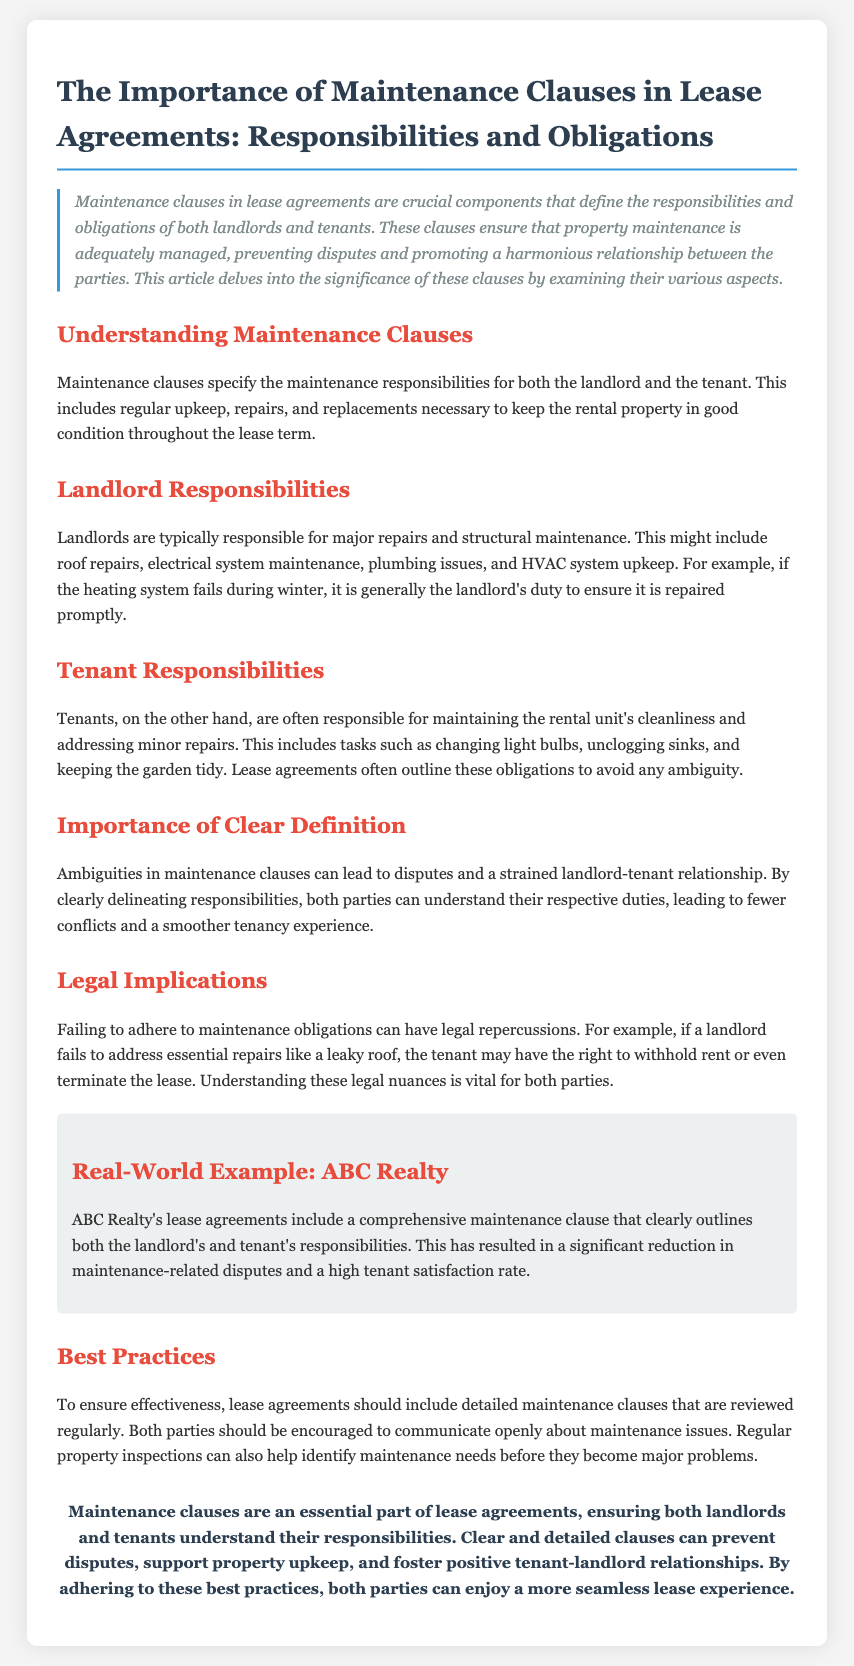What are maintenance clauses? Maintenance clauses specify the maintenance responsibilities for both the landlord and the tenant throughout the lease term.
Answer: Maintenance responsibilities Who is responsible for major repairs? Major repairs and structural maintenance are typically the responsibility of the landlord.
Answer: Landlord Give an example of a tenant responsibility. Tenant responsibilities include tasks such as changing light bulbs or unclogging sinks.
Answer: Changing light bulbs What can happen if a landlord fails to address essential repairs? Failing to address essential repairs can lead to legal repercussions such as the tenant withholding rent.
Answer: Withholding rent What is a best practice for lease agreements? A best practice is to include detailed maintenance clauses that are reviewed regularly.
Answer: Regular reviews What is the result of ABC Realty's comprehensive maintenance clause? The result has been a significant reduction in maintenance-related disputes and a high tenant satisfaction rate.
Answer: High tenant satisfaction rate 